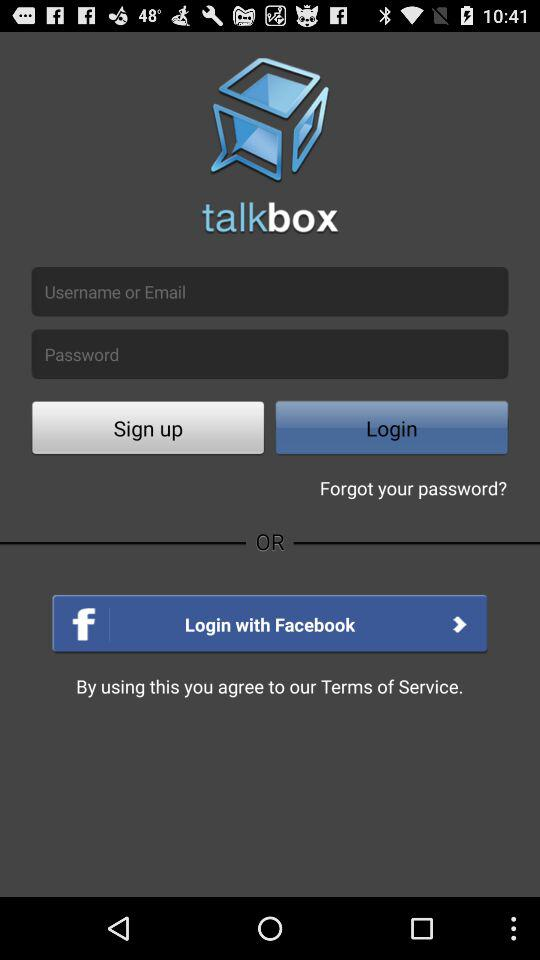What is the name of the application? The name of the application is "talkbox". 